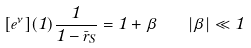Convert formula to latex. <formula><loc_0><loc_0><loc_500><loc_500>[ e ^ { \nu } ] ( 1 ) \frac { 1 } { 1 - \bar { r } _ { S } } = 1 + \beta \quad | \beta | \ll 1</formula> 